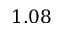<formula> <loc_0><loc_0><loc_500><loc_500>1 . 0 8</formula> 